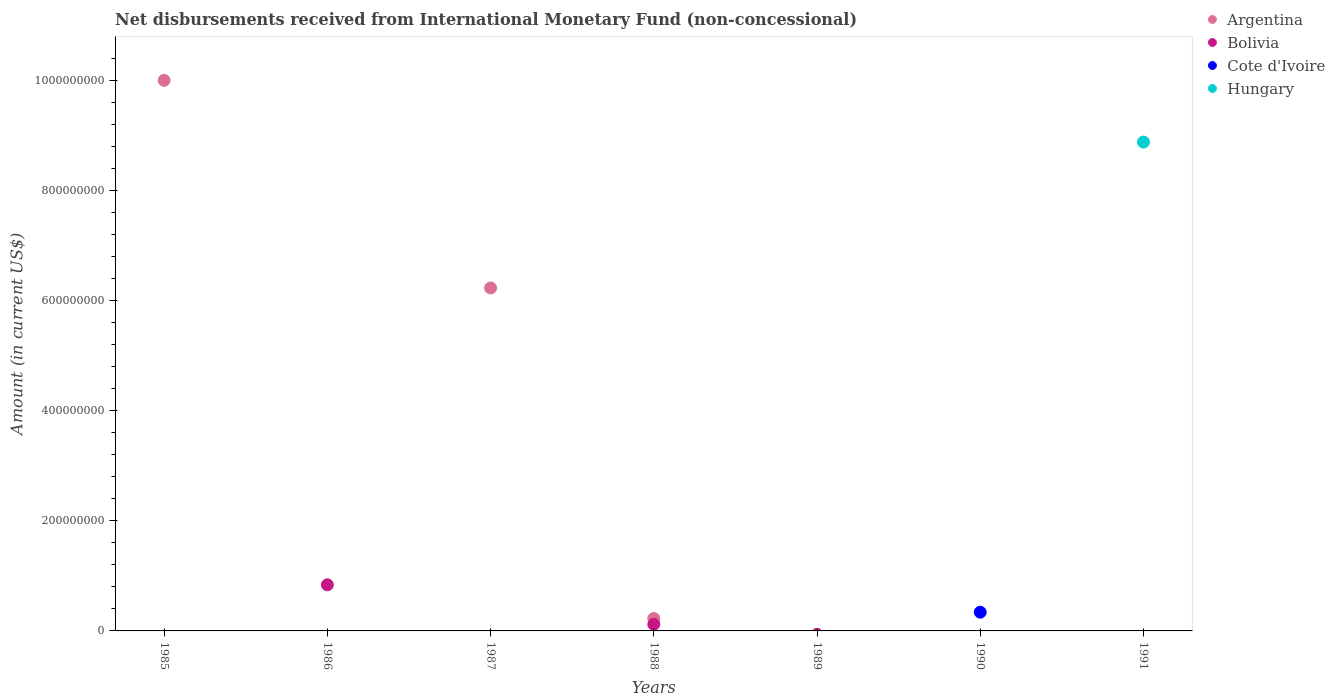How many different coloured dotlines are there?
Your answer should be compact. 4. What is the amount of disbursements received from International Monetary Fund in Hungary in 1985?
Your response must be concise. 0. Across all years, what is the maximum amount of disbursements received from International Monetary Fund in Argentina?
Offer a very short reply. 1.00e+09. Across all years, what is the minimum amount of disbursements received from International Monetary Fund in Cote d'Ivoire?
Keep it short and to the point. 0. What is the total amount of disbursements received from International Monetary Fund in Argentina in the graph?
Your answer should be compact. 1.64e+09. What is the difference between the amount of disbursements received from International Monetary Fund in Bolivia in 1991 and the amount of disbursements received from International Monetary Fund in Cote d'Ivoire in 1989?
Ensure brevity in your answer.  0. What is the average amount of disbursements received from International Monetary Fund in Bolivia per year?
Your response must be concise. 1.37e+07. What is the difference between the highest and the lowest amount of disbursements received from International Monetary Fund in Argentina?
Keep it short and to the point. 1.00e+09. In how many years, is the amount of disbursements received from International Monetary Fund in Cote d'Ivoire greater than the average amount of disbursements received from International Monetary Fund in Cote d'Ivoire taken over all years?
Keep it short and to the point. 1. Is it the case that in every year, the sum of the amount of disbursements received from International Monetary Fund in Bolivia and amount of disbursements received from International Monetary Fund in Hungary  is greater than the amount of disbursements received from International Monetary Fund in Argentina?
Offer a very short reply. No. Does the amount of disbursements received from International Monetary Fund in Argentina monotonically increase over the years?
Offer a very short reply. No. Is the amount of disbursements received from International Monetary Fund in Cote d'Ivoire strictly less than the amount of disbursements received from International Monetary Fund in Bolivia over the years?
Provide a short and direct response. No. How many dotlines are there?
Your answer should be compact. 4. What is the difference between two consecutive major ticks on the Y-axis?
Provide a short and direct response. 2.00e+08. Are the values on the major ticks of Y-axis written in scientific E-notation?
Give a very brief answer. No. Does the graph contain any zero values?
Offer a very short reply. Yes. Does the graph contain grids?
Offer a terse response. No. Where does the legend appear in the graph?
Your answer should be very brief. Top right. How many legend labels are there?
Provide a succinct answer. 4. How are the legend labels stacked?
Offer a terse response. Vertical. What is the title of the graph?
Provide a succinct answer. Net disbursements received from International Monetary Fund (non-concessional). What is the Amount (in current US$) of Argentina in 1985?
Ensure brevity in your answer.  1.00e+09. What is the Amount (in current US$) in Hungary in 1985?
Offer a very short reply. 0. What is the Amount (in current US$) in Bolivia in 1986?
Offer a terse response. 8.37e+07. What is the Amount (in current US$) in Argentina in 1987?
Make the answer very short. 6.23e+08. What is the Amount (in current US$) of Cote d'Ivoire in 1987?
Ensure brevity in your answer.  0. What is the Amount (in current US$) in Argentina in 1988?
Provide a succinct answer. 2.25e+07. What is the Amount (in current US$) in Bolivia in 1988?
Ensure brevity in your answer.  1.20e+07. What is the Amount (in current US$) of Cote d'Ivoire in 1988?
Provide a succinct answer. 0. What is the Amount (in current US$) of Hungary in 1989?
Your answer should be compact. 0. What is the Amount (in current US$) of Argentina in 1990?
Your answer should be compact. 0. What is the Amount (in current US$) in Bolivia in 1990?
Your answer should be very brief. 0. What is the Amount (in current US$) in Cote d'Ivoire in 1990?
Give a very brief answer. 3.40e+07. What is the Amount (in current US$) in Hungary in 1991?
Provide a succinct answer. 8.88e+08. Across all years, what is the maximum Amount (in current US$) in Argentina?
Provide a short and direct response. 1.00e+09. Across all years, what is the maximum Amount (in current US$) in Bolivia?
Keep it short and to the point. 8.37e+07. Across all years, what is the maximum Amount (in current US$) in Cote d'Ivoire?
Provide a succinct answer. 3.40e+07. Across all years, what is the maximum Amount (in current US$) of Hungary?
Provide a short and direct response. 8.88e+08. Across all years, what is the minimum Amount (in current US$) of Argentina?
Your response must be concise. 0. Across all years, what is the minimum Amount (in current US$) in Bolivia?
Provide a succinct answer. 0. Across all years, what is the minimum Amount (in current US$) of Hungary?
Provide a succinct answer. 0. What is the total Amount (in current US$) of Argentina in the graph?
Your response must be concise. 1.64e+09. What is the total Amount (in current US$) of Bolivia in the graph?
Your answer should be very brief. 9.58e+07. What is the total Amount (in current US$) in Cote d'Ivoire in the graph?
Offer a very short reply. 3.40e+07. What is the total Amount (in current US$) of Hungary in the graph?
Provide a short and direct response. 8.88e+08. What is the difference between the Amount (in current US$) of Argentina in 1985 and that in 1987?
Offer a very short reply. 3.77e+08. What is the difference between the Amount (in current US$) in Argentina in 1985 and that in 1988?
Offer a terse response. 9.77e+08. What is the difference between the Amount (in current US$) of Bolivia in 1986 and that in 1988?
Offer a very short reply. 7.17e+07. What is the difference between the Amount (in current US$) in Argentina in 1987 and that in 1988?
Your answer should be compact. 6.00e+08. What is the difference between the Amount (in current US$) of Argentina in 1985 and the Amount (in current US$) of Bolivia in 1986?
Your answer should be compact. 9.16e+08. What is the difference between the Amount (in current US$) in Argentina in 1985 and the Amount (in current US$) in Bolivia in 1988?
Offer a terse response. 9.88e+08. What is the difference between the Amount (in current US$) in Argentina in 1985 and the Amount (in current US$) in Cote d'Ivoire in 1990?
Offer a very short reply. 9.66e+08. What is the difference between the Amount (in current US$) in Argentina in 1985 and the Amount (in current US$) in Hungary in 1991?
Your answer should be compact. 1.12e+08. What is the difference between the Amount (in current US$) of Bolivia in 1986 and the Amount (in current US$) of Cote d'Ivoire in 1990?
Keep it short and to the point. 4.97e+07. What is the difference between the Amount (in current US$) in Bolivia in 1986 and the Amount (in current US$) in Hungary in 1991?
Provide a succinct answer. -8.04e+08. What is the difference between the Amount (in current US$) of Argentina in 1987 and the Amount (in current US$) of Bolivia in 1988?
Your response must be concise. 6.11e+08. What is the difference between the Amount (in current US$) in Argentina in 1987 and the Amount (in current US$) in Cote d'Ivoire in 1990?
Provide a succinct answer. 5.89e+08. What is the difference between the Amount (in current US$) of Argentina in 1987 and the Amount (in current US$) of Hungary in 1991?
Your answer should be very brief. -2.65e+08. What is the difference between the Amount (in current US$) of Argentina in 1988 and the Amount (in current US$) of Cote d'Ivoire in 1990?
Offer a very short reply. -1.15e+07. What is the difference between the Amount (in current US$) of Bolivia in 1988 and the Amount (in current US$) of Cote d'Ivoire in 1990?
Give a very brief answer. -2.20e+07. What is the difference between the Amount (in current US$) in Argentina in 1988 and the Amount (in current US$) in Hungary in 1991?
Ensure brevity in your answer.  -8.65e+08. What is the difference between the Amount (in current US$) of Bolivia in 1988 and the Amount (in current US$) of Hungary in 1991?
Make the answer very short. -8.76e+08. What is the difference between the Amount (in current US$) in Cote d'Ivoire in 1990 and the Amount (in current US$) in Hungary in 1991?
Your answer should be compact. -8.54e+08. What is the average Amount (in current US$) of Argentina per year?
Make the answer very short. 2.35e+08. What is the average Amount (in current US$) of Bolivia per year?
Offer a terse response. 1.37e+07. What is the average Amount (in current US$) of Cote d'Ivoire per year?
Make the answer very short. 4.86e+06. What is the average Amount (in current US$) of Hungary per year?
Give a very brief answer. 1.27e+08. In the year 1988, what is the difference between the Amount (in current US$) of Argentina and Amount (in current US$) of Bolivia?
Ensure brevity in your answer.  1.05e+07. What is the ratio of the Amount (in current US$) of Argentina in 1985 to that in 1987?
Provide a short and direct response. 1.61. What is the ratio of the Amount (in current US$) in Argentina in 1985 to that in 1988?
Offer a terse response. 44.37. What is the ratio of the Amount (in current US$) of Bolivia in 1986 to that in 1988?
Offer a very short reply. 6.97. What is the ratio of the Amount (in current US$) in Argentina in 1987 to that in 1988?
Provide a short and direct response. 27.64. What is the difference between the highest and the second highest Amount (in current US$) in Argentina?
Offer a terse response. 3.77e+08. What is the difference between the highest and the lowest Amount (in current US$) of Argentina?
Keep it short and to the point. 1.00e+09. What is the difference between the highest and the lowest Amount (in current US$) in Bolivia?
Your answer should be compact. 8.37e+07. What is the difference between the highest and the lowest Amount (in current US$) of Cote d'Ivoire?
Give a very brief answer. 3.40e+07. What is the difference between the highest and the lowest Amount (in current US$) in Hungary?
Ensure brevity in your answer.  8.88e+08. 